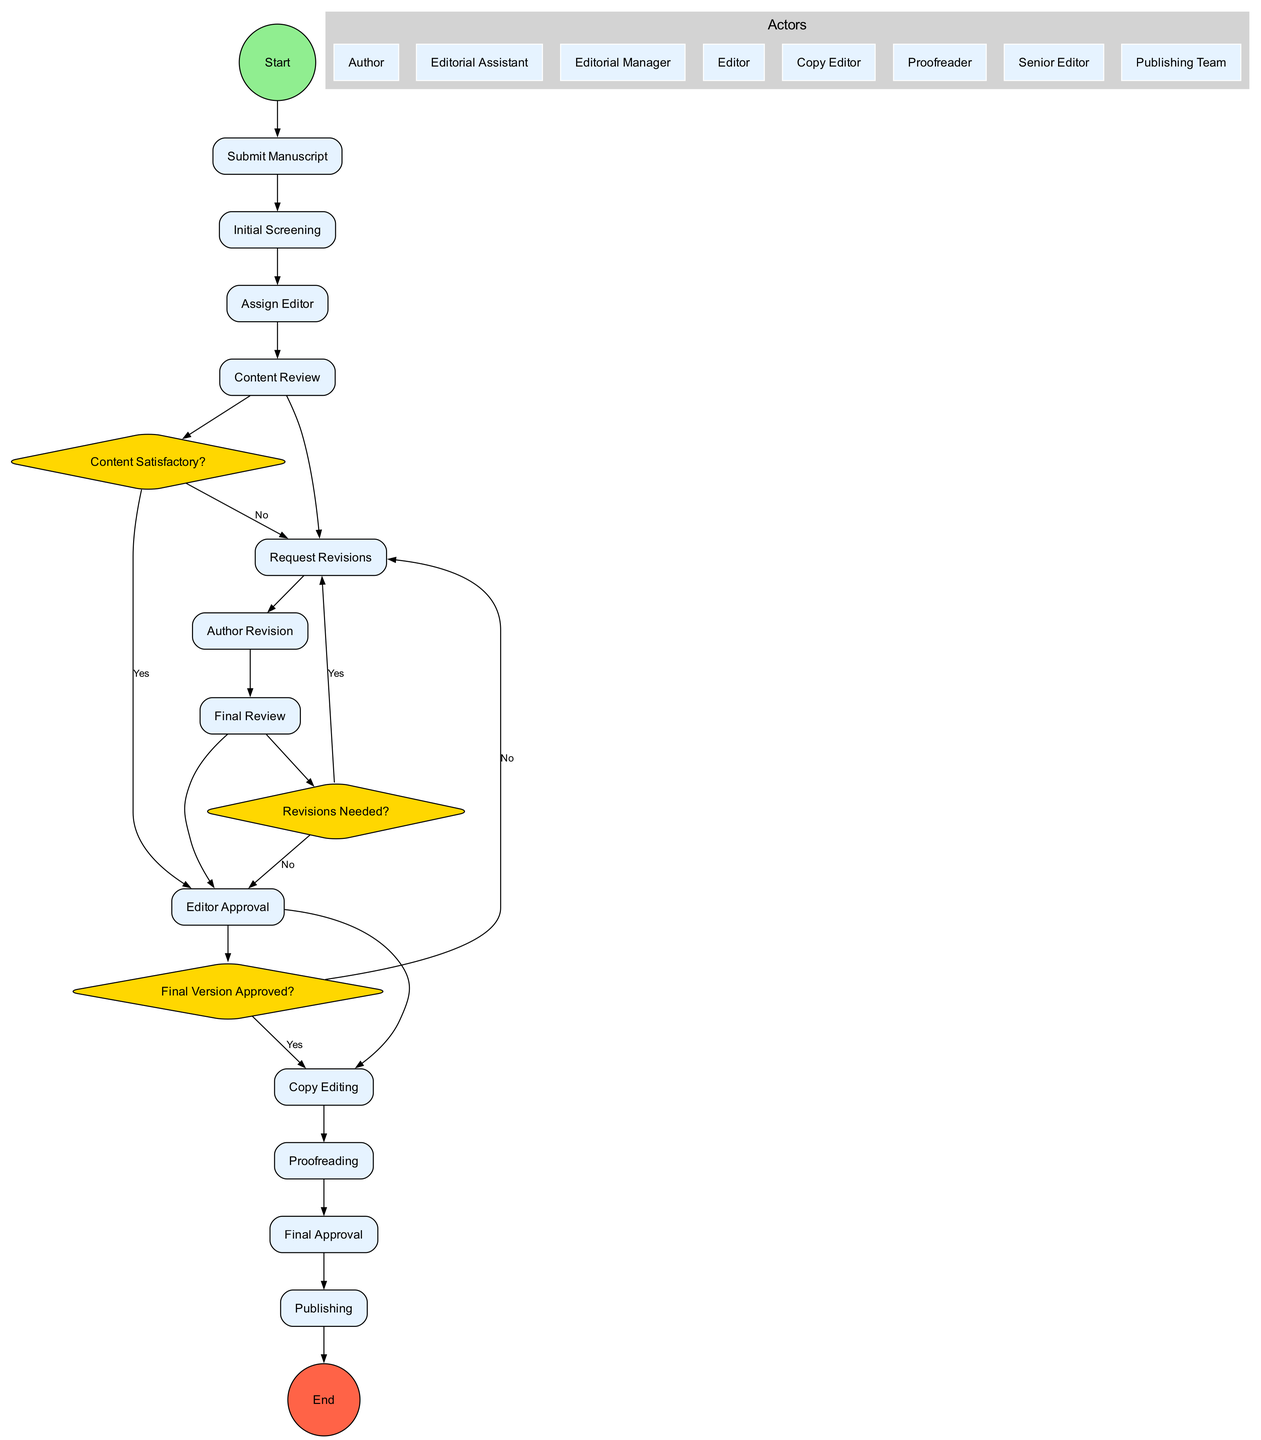What is the first activity in the workflow? The diagram indicates that the first activity, the starting point, is labeled as "Submit Manuscript." This is the first task that an author performs in the workflow.
Answer: Submit Manuscript How many decision points are in the diagram? By reviewing the diagram, we can see that there are three distinct decision points represented by diamond shapes: "Content Satisfactory?", "Revisions Needed?", and "Final Version Approved?". Adding these gives us a total of three decision points.
Answer: 3 Who performs the "Content Review"? According to the diagram, the "Content Review" activity is assigned to the "Editor." This role is responsible for evaluating the manuscript for quality and compliance with guidelines.
Answer: Editor What happens if the response to "Final Version Approved?" is no? If the decision at this point is "No," the diagram indicates that the workflow loops back to the "Copy Editing" step for further changes or adjustments. This means that the manuscript requires additional work before final approval.
Answer: Copy Editing How many activities are listed in the workflow? Counting the activities outlined in the diagram, there are a total of 12 activities from "Submit Manuscript" to "Publishing," inclusive. Therefore, the total number of activities is twelve.
Answer: 12 What occurs after "Author Revision"? Following "Author Revision," there is a decision point labeled "Revisions Needed?" If further revisions are required, the workflow goes back to "Request Revisions." If not, it proceeds to "Final Review." This shows a clear flow based on the editor’s assessment of the manuscript.
Answer: Decision Point Which role is responsible for final approval of the manuscript? The "Final Approval" activity is conducted by the "Senior Editor." This individual has the responsibility of giving a final green light before the manuscript moves on to publication.
Answer: Senior Editor What activity comes directly after "Proofreading"? After "Proofreading," the next activity in the diagram is "Final Approval," indicating that this step is crucial as it represents the last chance to catch errors before publication.
Answer: Final Approval 